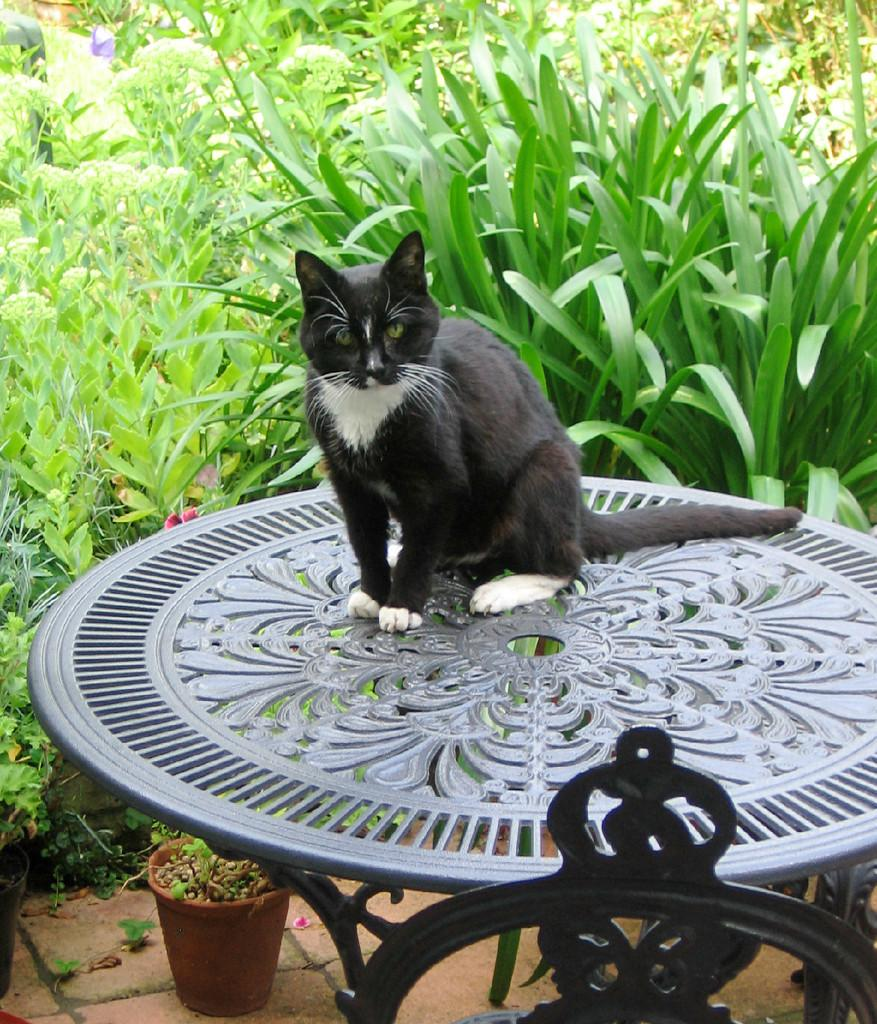What type of animal is in the image? There is a cat in the image. Where is the cat located? The cat is on a table. What is the color of the cat? The cat is black in color. What can be seen in the background of the image? There are trees visible in the image. Can you see the cat using a gun in the image? There is no gun present in the image, and the cat is not using any object as a gun. 